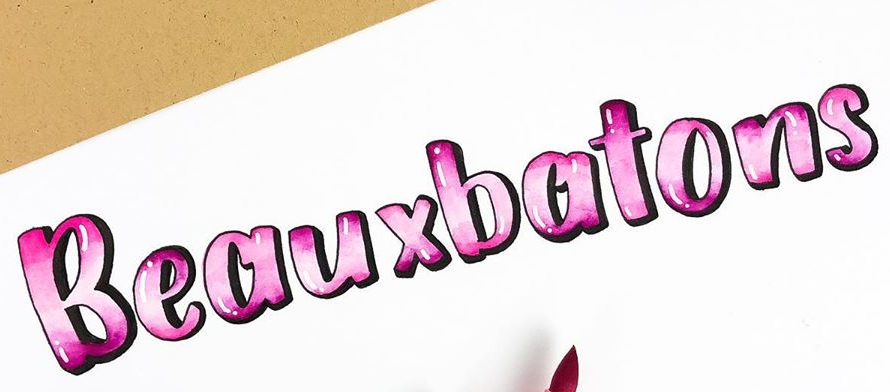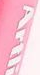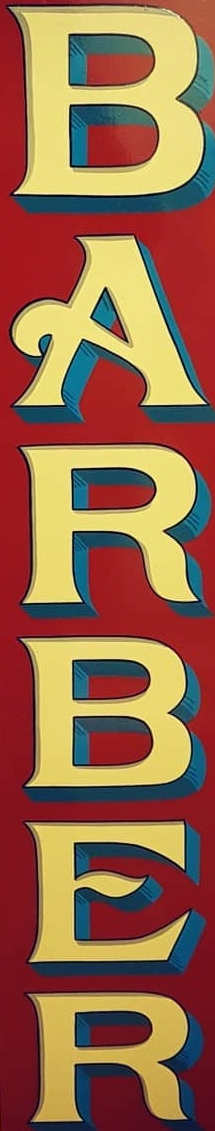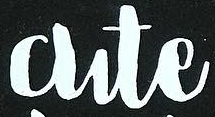What text appears in these images from left to right, separated by a semicolon? Beauxbatons; Artli; BARBER; Cute 